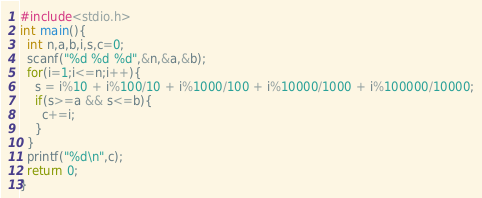Convert code to text. <code><loc_0><loc_0><loc_500><loc_500><_C_>#include<stdio.h>
int main(){
  int n,a,b,i,s,c=0;
  scanf("%d %d %d",&n,&a,&b);
  for(i=1;i<=n;i++){
    s = i%10 + i%100/10 + i%1000/100 + i%10000/1000 + i%100000/10000;
    if(s>=a && s<=b){
      c+=i;
    }
  }
  printf("%d\n",c);
  return 0;
}</code> 